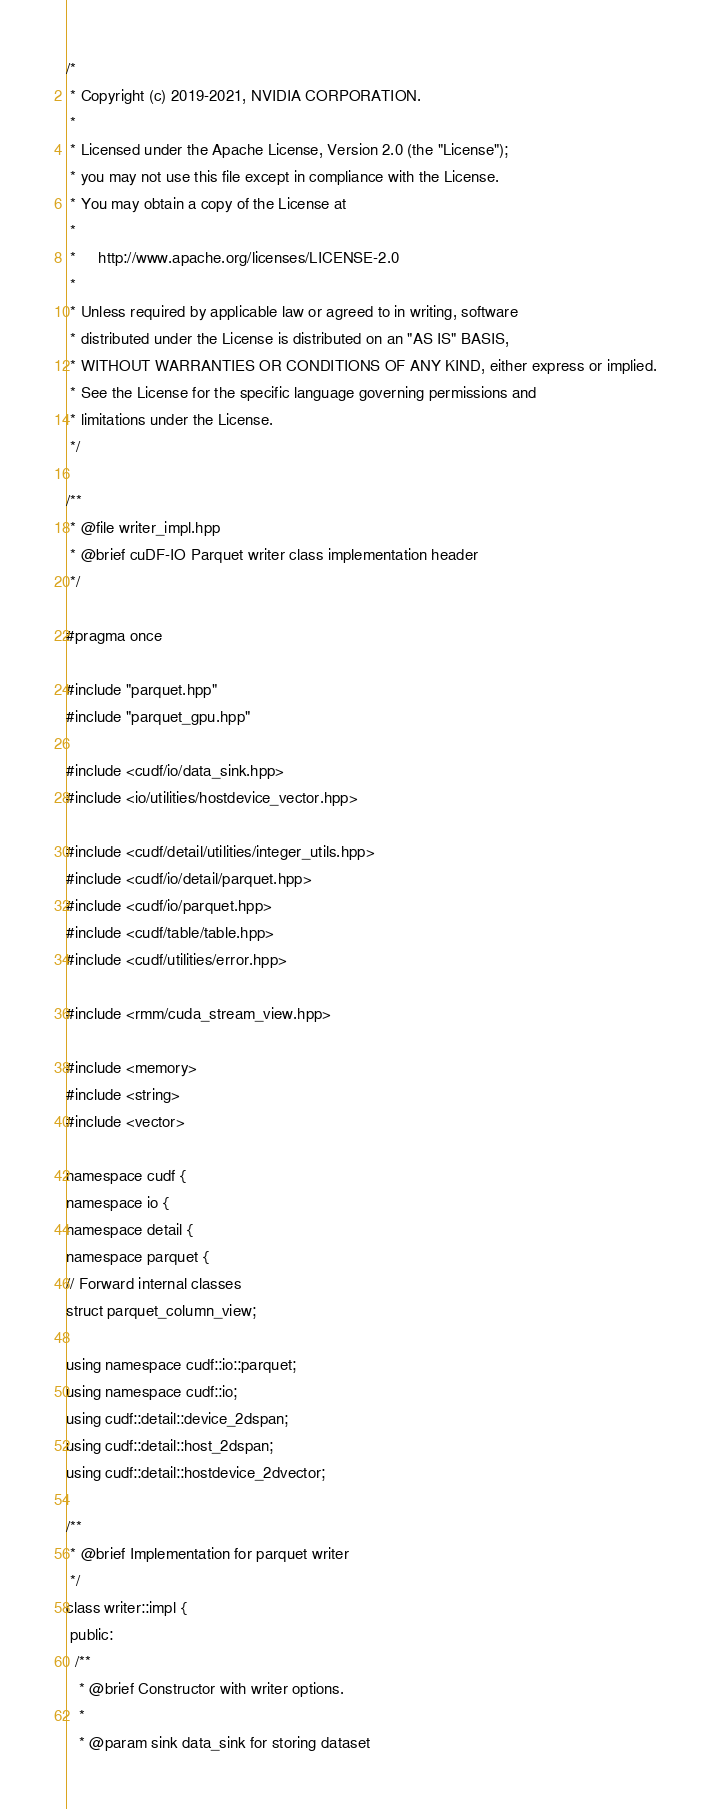<code> <loc_0><loc_0><loc_500><loc_500><_C++_>/*
 * Copyright (c) 2019-2021, NVIDIA CORPORATION.
 *
 * Licensed under the Apache License, Version 2.0 (the "License");
 * you may not use this file except in compliance with the License.
 * You may obtain a copy of the License at
 *
 *     http://www.apache.org/licenses/LICENSE-2.0
 *
 * Unless required by applicable law or agreed to in writing, software
 * distributed under the License is distributed on an "AS IS" BASIS,
 * WITHOUT WARRANTIES OR CONDITIONS OF ANY KIND, either express or implied.
 * See the License for the specific language governing permissions and
 * limitations under the License.
 */

/**
 * @file writer_impl.hpp
 * @brief cuDF-IO Parquet writer class implementation header
 */

#pragma once

#include "parquet.hpp"
#include "parquet_gpu.hpp"

#include <cudf/io/data_sink.hpp>
#include <io/utilities/hostdevice_vector.hpp>

#include <cudf/detail/utilities/integer_utils.hpp>
#include <cudf/io/detail/parquet.hpp>
#include <cudf/io/parquet.hpp>
#include <cudf/table/table.hpp>
#include <cudf/utilities/error.hpp>

#include <rmm/cuda_stream_view.hpp>

#include <memory>
#include <string>
#include <vector>

namespace cudf {
namespace io {
namespace detail {
namespace parquet {
// Forward internal classes
struct parquet_column_view;

using namespace cudf::io::parquet;
using namespace cudf::io;
using cudf::detail::device_2dspan;
using cudf::detail::host_2dspan;
using cudf::detail::hostdevice_2dvector;

/**
 * @brief Implementation for parquet writer
 */
class writer::impl {
 public:
  /**
   * @brief Constructor with writer options.
   *
   * @param sink data_sink for storing dataset</code> 